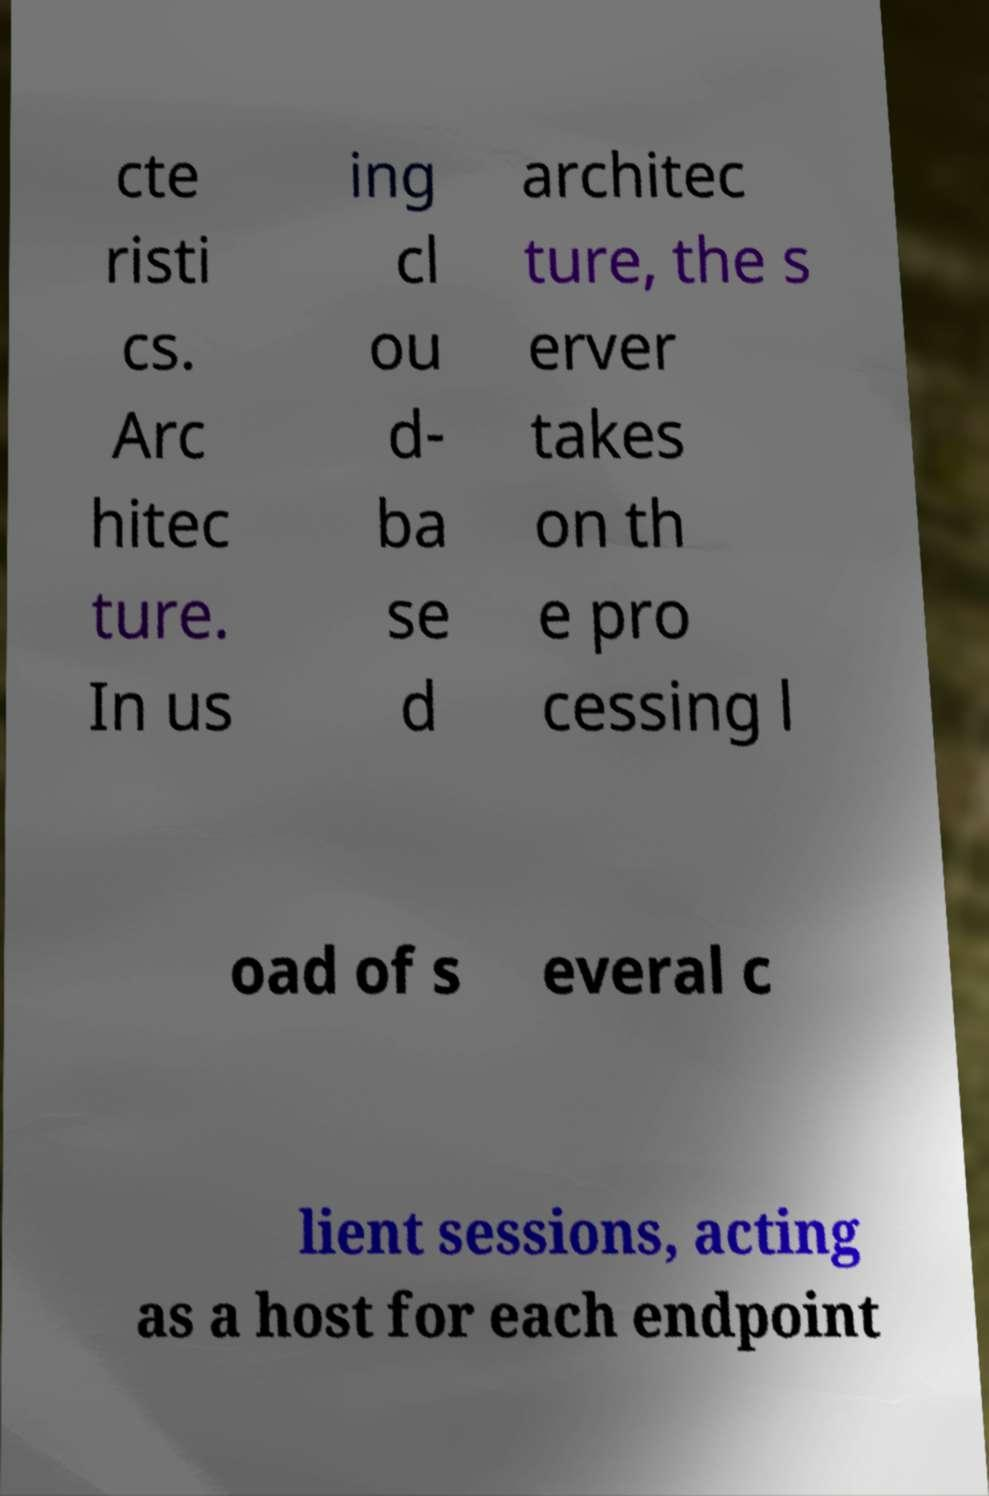Can you read and provide the text displayed in the image?This photo seems to have some interesting text. Can you extract and type it out for me? cte risti cs. Arc hitec ture. In us ing cl ou d- ba se d architec ture, the s erver takes on th e pro cessing l oad of s everal c lient sessions, acting as a host for each endpoint 